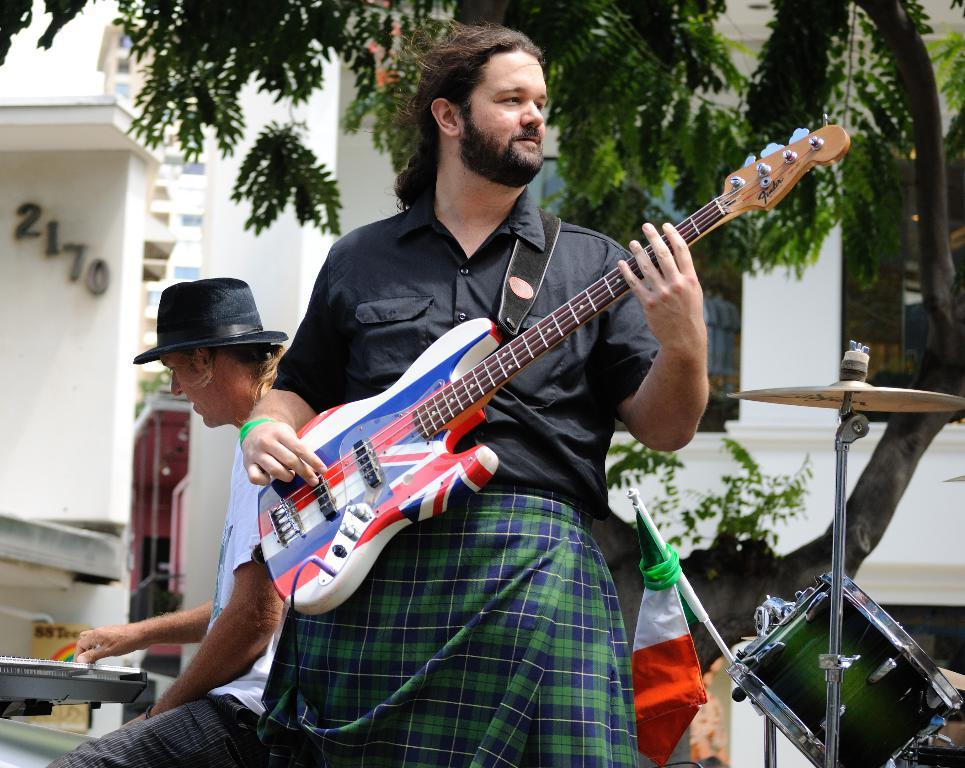How many people are in the image? There are two persons in the image. What are the persons doing in the image? The persons are playing musical instruments. What can be seen in the background of the image? There is a building and a tree in the background of the image. How many icicles are hanging from the tree in the image? There are no icicles present in the image; it only features a tree in the background. A: The image? in the background of the image? in the image? in the image? in the image? in the image? in the image? in the image? in the image? in the image? in the image? in the image? in the image? in the image? in the image? in the image? in the image? in the image? in the image? in the image? in the image? in the image? in the image? in the image? in the image? in the image? in the image? in the image? in the image? in the image? in the image? in the image? in the image? in the image? in the image? in the image? in the image? in the image? in the image? in the image? in the image? in the image? in the image? in the image? in the image? in the image? in the image? in the image? in the image? in the image? in the image? in the image? in the image? in the image? in the image? in the image? in the image? in the image? in the image? in the image? in the image? in the image? in the image? in the image? in the image? in the image? in the image? in the image? in the image? in the image? in the image? in the image? in the image? in the image? in the image? in the image? in the image? in the image? in the image? in the image? in the image? in the image? in the image? in the image? in the image? in the image? in the image? in the image? in the image? in the image? in the image? in the image? in the image? in the image? in the image? in the image? in the image? in the image? in the image? in the image? in the image? in the image? in the image? in the image? in the image? in the image? in the image? in the image? in the image? in the image? in the image? in the image? in the image? in the image? in the image? in the image? in the image? in the image? in the image? in the image? in the image? in the image? in the image? in the image? in the image? in the image? in the image? in the image? in the image? in the image? in the image? in the image? in the image? in the image? in the image? in the image? in the image? in the image? in the image? in the image? in 